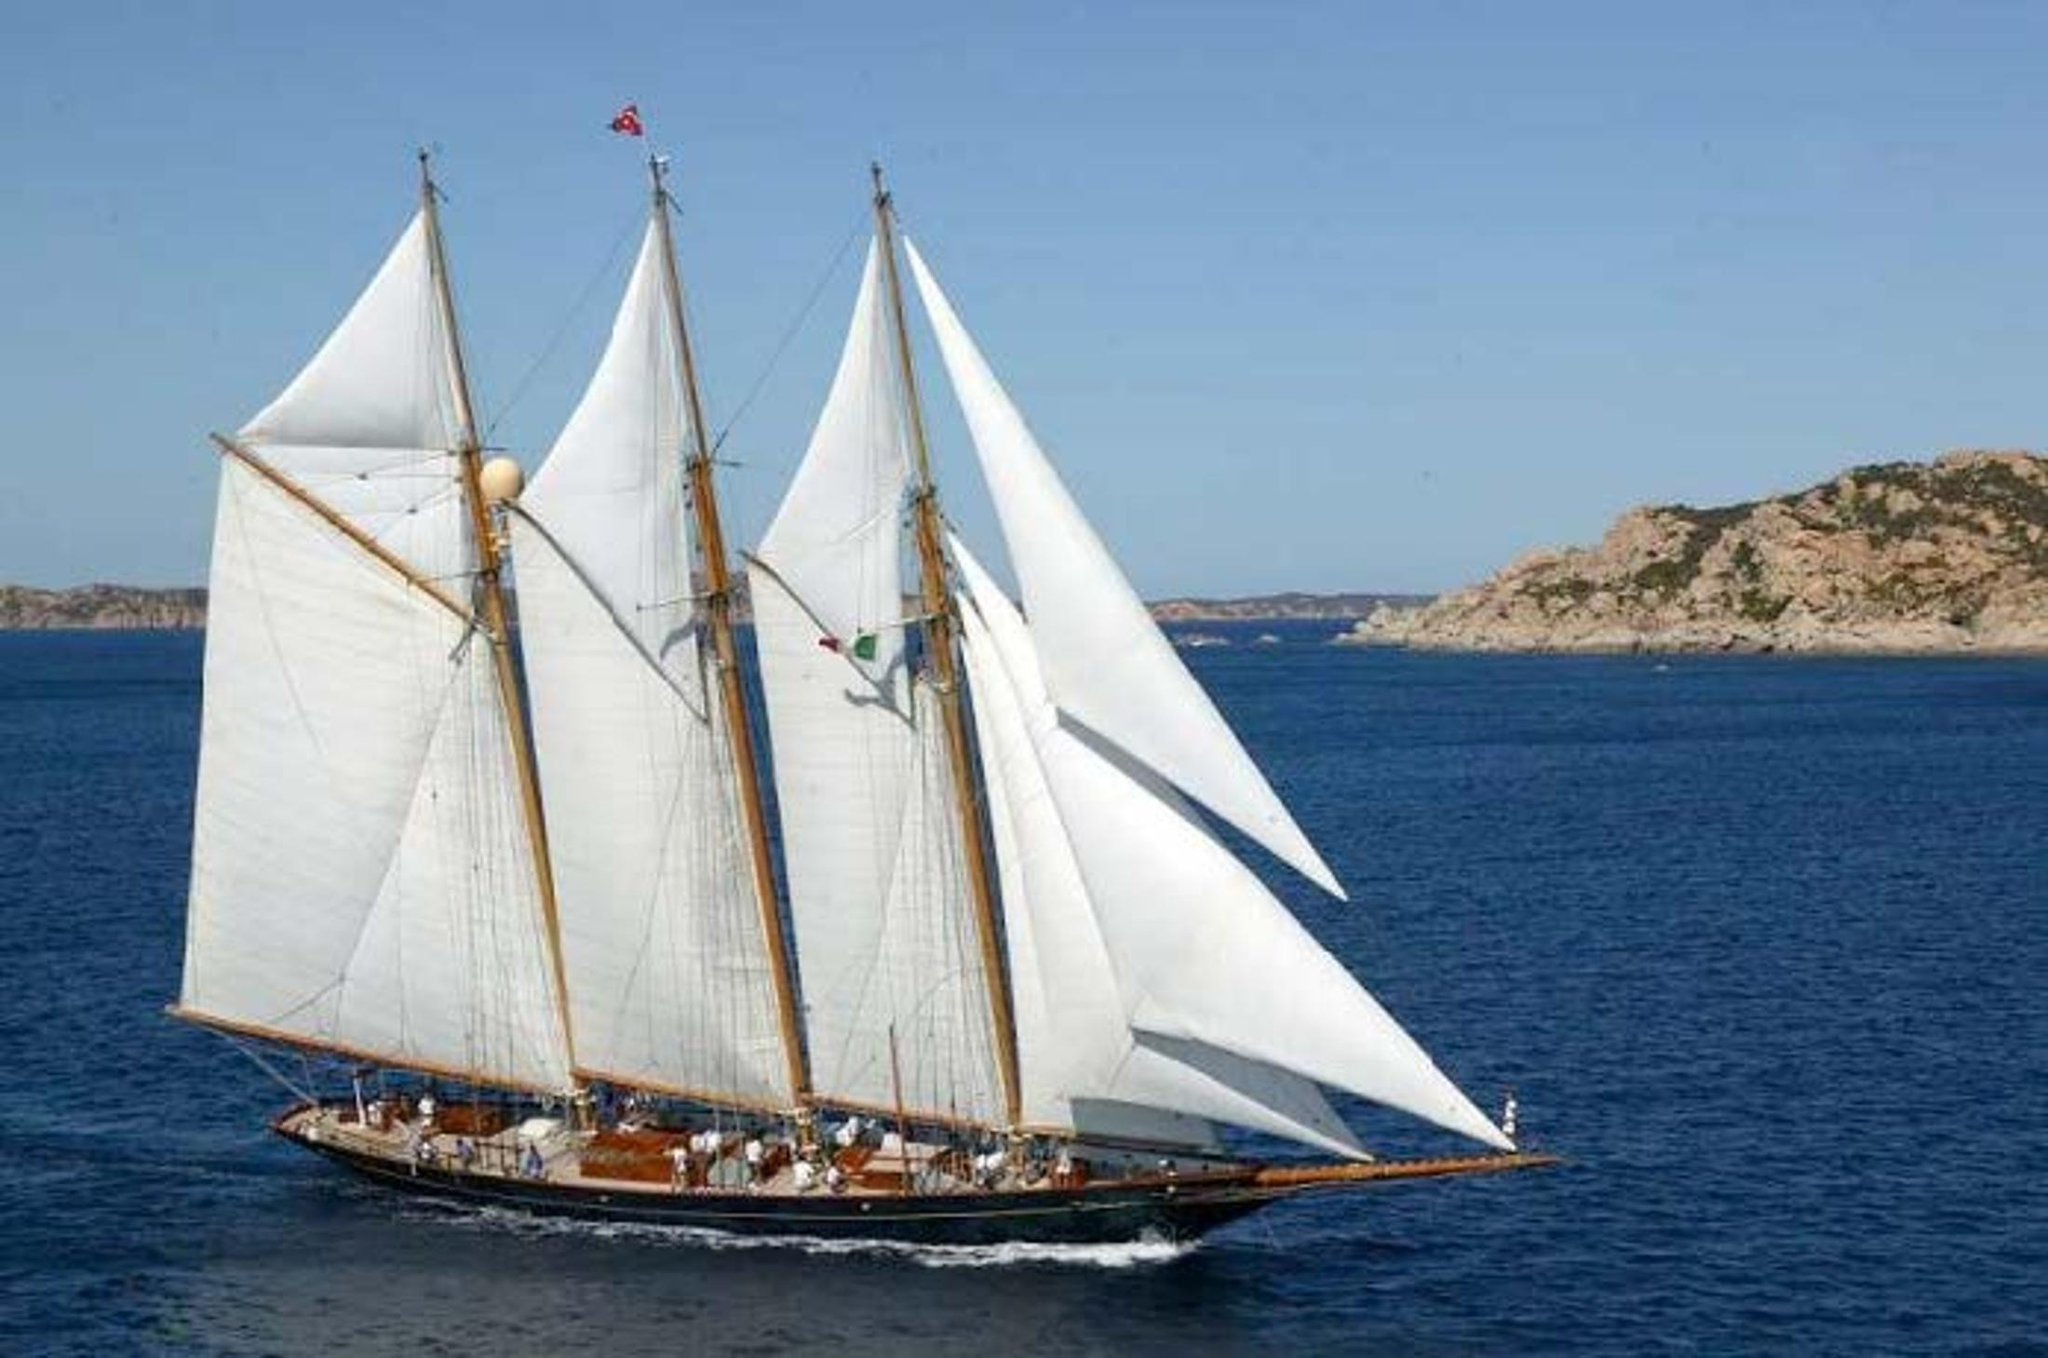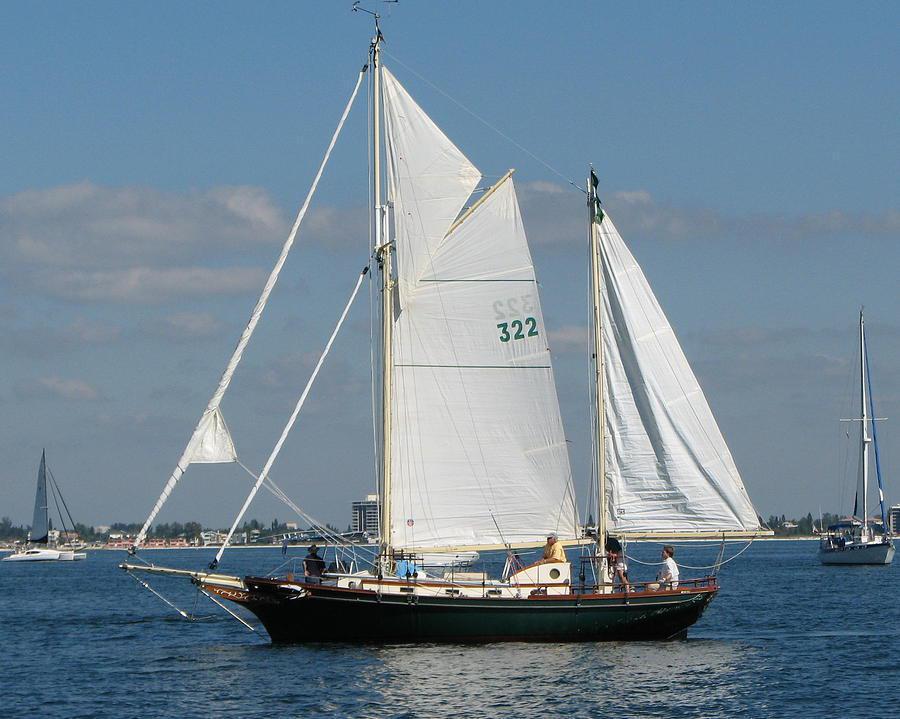The first image is the image on the left, the second image is the image on the right. Assess this claim about the two images: "The two boats are heading towards each other.". Correct or not? Answer yes or no. Yes. The first image is the image on the left, the second image is the image on the right. Evaluate the accuracy of this statement regarding the images: "One sailboat has a dark exterior and no more than four sails.". Is it true? Answer yes or no. Yes. The first image is the image on the left, the second image is the image on the right. Considering the images on both sides, is "The boat in the image on the right is lighter in color than the boat in the image on the left." valid? Answer yes or no. No. The first image is the image on the left, the second image is the image on the right. Assess this claim about the two images: "There are two white sailboats on the water.". Correct or not? Answer yes or no. No. 